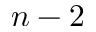<formula> <loc_0><loc_0><loc_500><loc_500>n - 2</formula> 